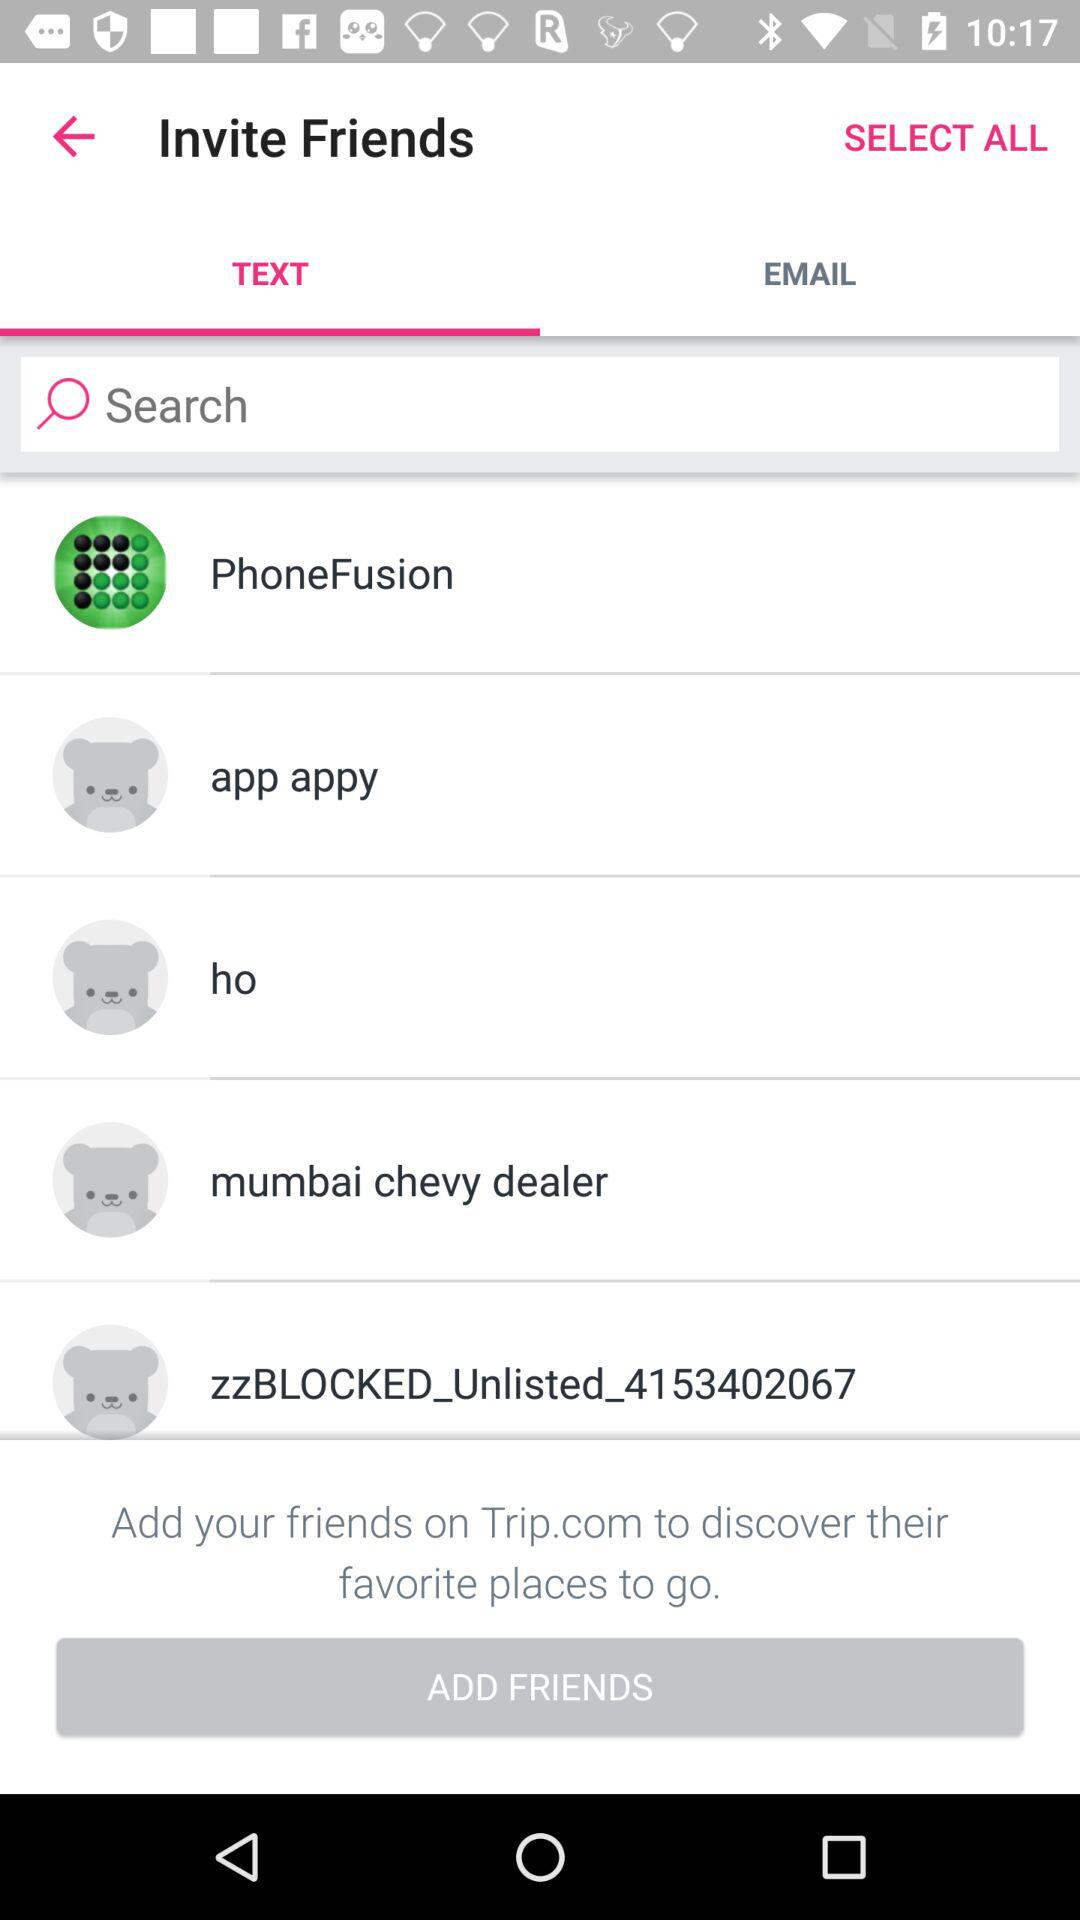What is the selected tab? The selected tab is "TEXT". 